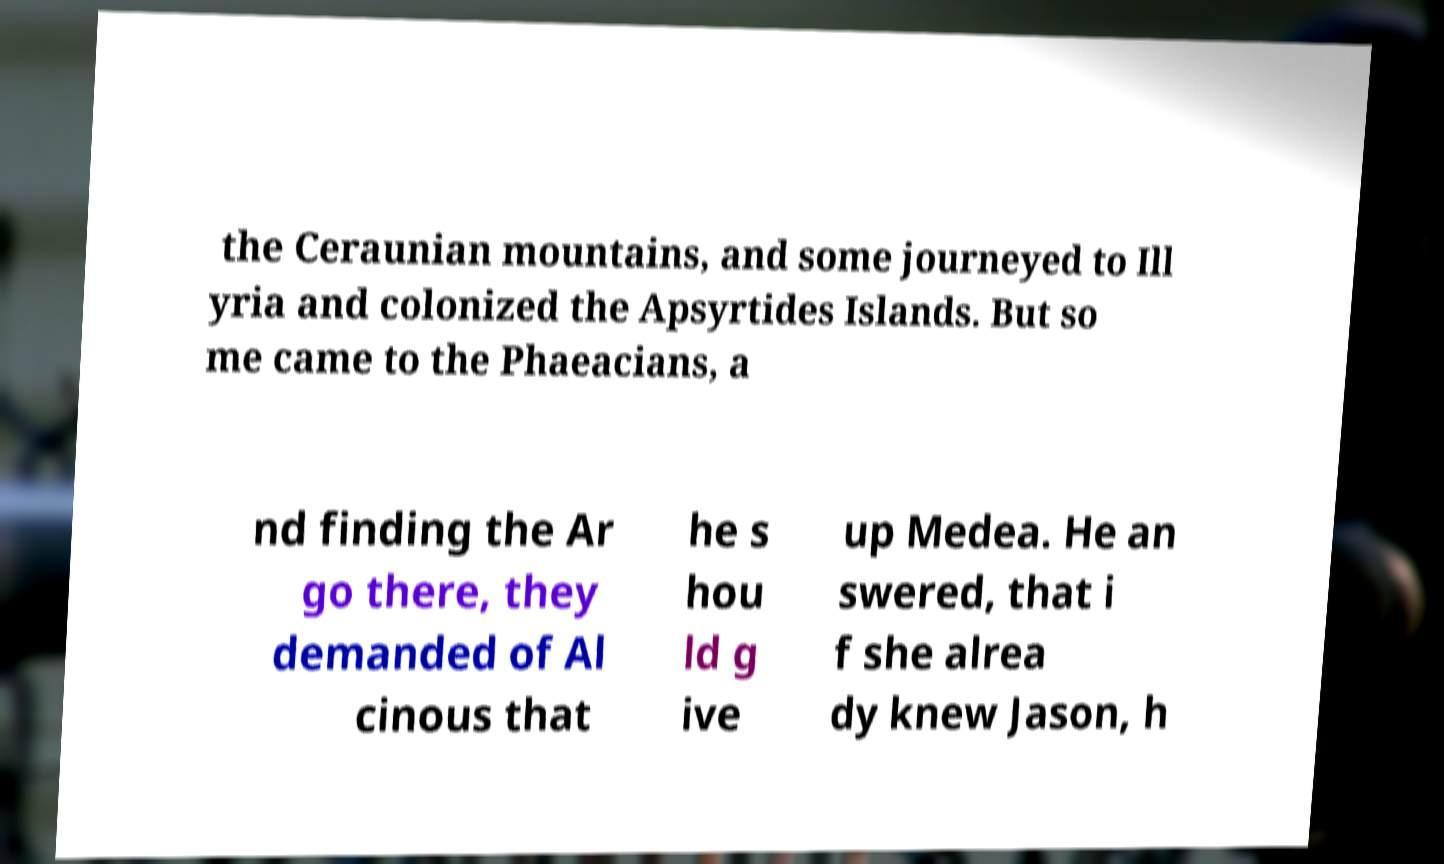There's text embedded in this image that I need extracted. Can you transcribe it verbatim? the Ceraunian mountains, and some journeyed to Ill yria and colonized the Apsyrtides Islands. But so me came to the Phaeacians, a nd finding the Ar go there, they demanded of Al cinous that he s hou ld g ive up Medea. He an swered, that i f she alrea dy knew Jason, h 